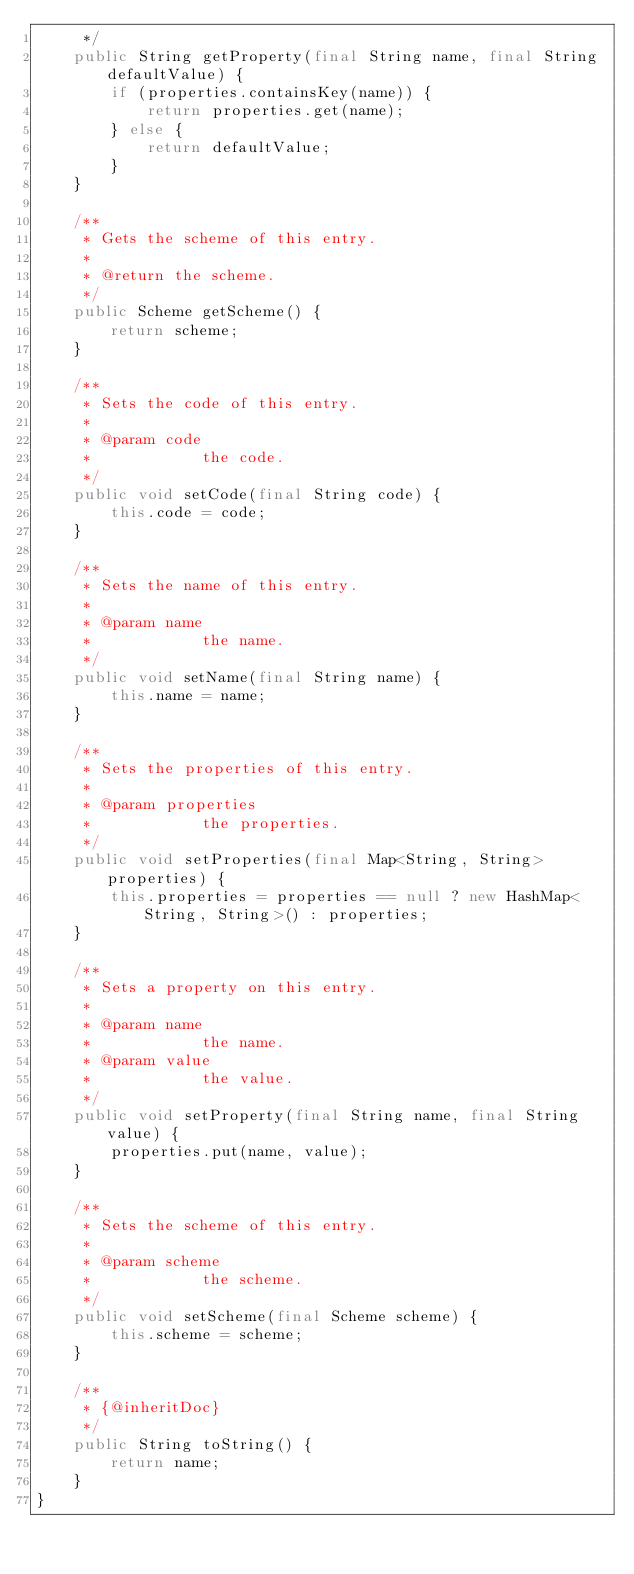<code> <loc_0><loc_0><loc_500><loc_500><_Java_>	 */
	public String getProperty(final String name, final String defaultValue) {
		if (properties.containsKey(name)) {
			return properties.get(name);
		} else {
			return defaultValue;
		}
	}

	/**
	 * Gets the scheme of this entry.
	 * 
	 * @return the scheme.
	 */
	public Scheme getScheme() {
		return scheme;
	}

	/**
	 * Sets the code of this entry.
	 * 
	 * @param code
	 *            the code.
	 */
	public void setCode(final String code) {
		this.code = code;
	}

	/**
	 * Sets the name of this entry.
	 * 
	 * @param name
	 *            the name.
	 */
	public void setName(final String name) {
		this.name = name;
	}

	/**
	 * Sets the properties of this entry.
	 * 
	 * @param properties
	 *            the properties.
	 */
	public void setProperties(final Map<String, String> properties) {
		this.properties = properties == null ? new HashMap<String, String>() : properties;
	}

	/**
	 * Sets a property on this entry.
	 * 
	 * @param name
	 *            the name.
	 * @param value
	 *            the value.
	 */
	public void setProperty(final String name, final String value) {
		properties.put(name, value);
	}

	/**
	 * Sets the scheme of this entry.
	 * 
	 * @param scheme
	 *            the scheme.
	 */
	public void setScheme(final Scheme scheme) {
		this.scheme = scheme;
	}
	
	/**
	 * {@inheritDoc}
	 */
	public String toString() {
		return name;
	}
}
</code> 